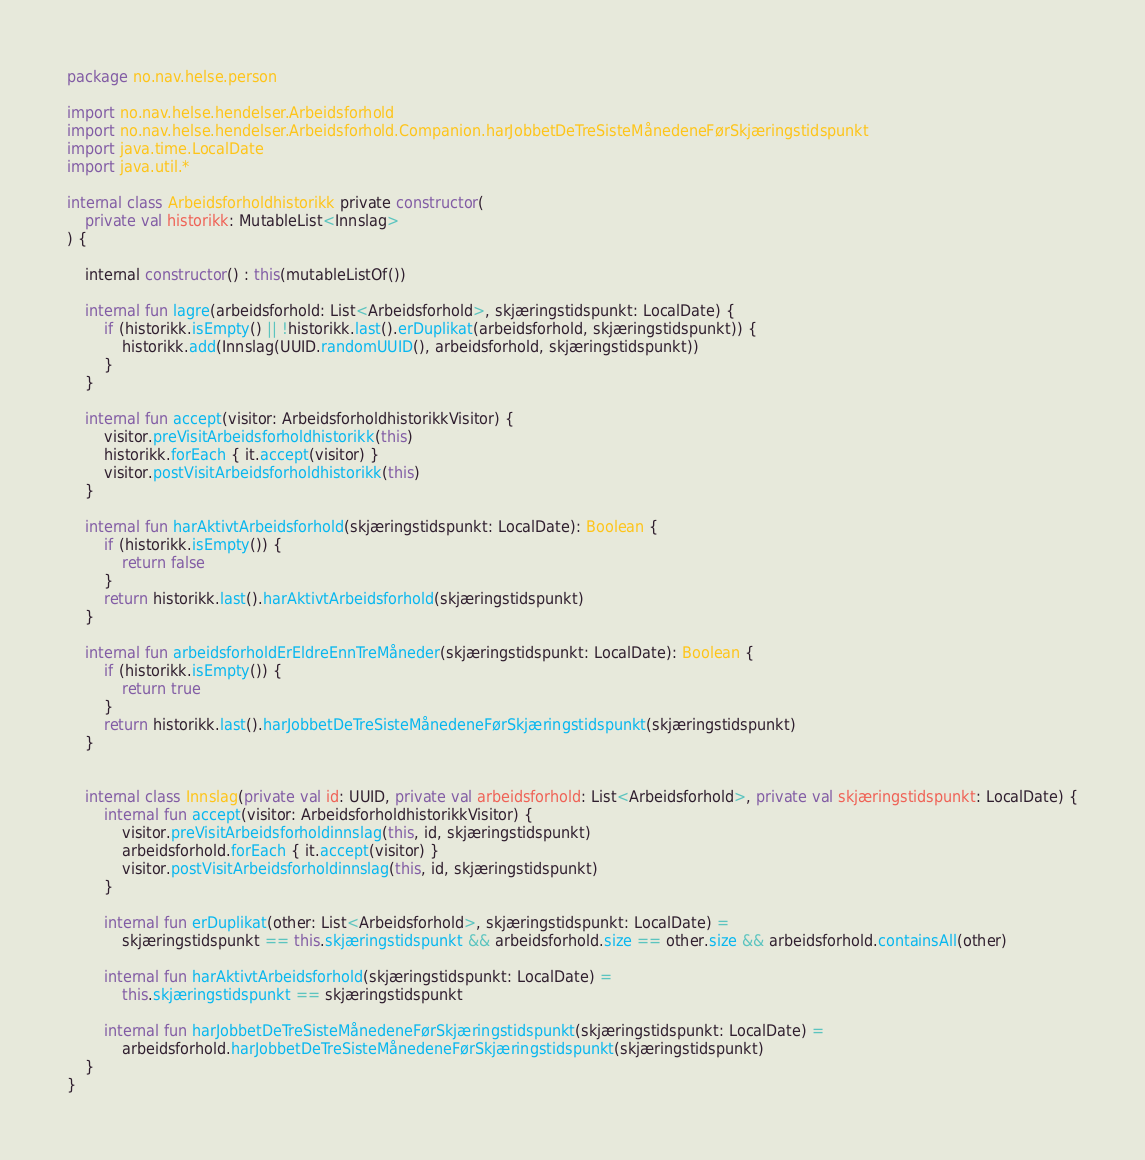Convert code to text. <code><loc_0><loc_0><loc_500><loc_500><_Kotlin_>package no.nav.helse.person

import no.nav.helse.hendelser.Arbeidsforhold
import no.nav.helse.hendelser.Arbeidsforhold.Companion.harJobbetDeTreSisteMånedeneFørSkjæringstidspunkt
import java.time.LocalDate
import java.util.*

internal class Arbeidsforholdhistorikk private constructor(
    private val historikk: MutableList<Innslag>
) {

    internal constructor() : this(mutableListOf())

    internal fun lagre(arbeidsforhold: List<Arbeidsforhold>, skjæringstidspunkt: LocalDate) {
        if (historikk.isEmpty() || !historikk.last().erDuplikat(arbeidsforhold, skjæringstidspunkt)) {
            historikk.add(Innslag(UUID.randomUUID(), arbeidsforhold, skjæringstidspunkt))
        }
    }

    internal fun accept(visitor: ArbeidsforholdhistorikkVisitor) {
        visitor.preVisitArbeidsforholdhistorikk(this)
        historikk.forEach { it.accept(visitor) }
        visitor.postVisitArbeidsforholdhistorikk(this)
    }

    internal fun harAktivtArbeidsforhold(skjæringstidspunkt: LocalDate): Boolean {
        if (historikk.isEmpty()) {
            return false
        }
        return historikk.last().harAktivtArbeidsforhold(skjæringstidspunkt)
    }

    internal fun arbeidsforholdErEldreEnnTreMåneder(skjæringstidspunkt: LocalDate): Boolean {
        if (historikk.isEmpty()) {
            return true
        }
        return historikk.last().harJobbetDeTreSisteMånedeneFørSkjæringstidspunkt(skjæringstidspunkt)
    }


    internal class Innslag(private val id: UUID, private val arbeidsforhold: List<Arbeidsforhold>, private val skjæringstidspunkt: LocalDate) {
        internal fun accept(visitor: ArbeidsforholdhistorikkVisitor) {
            visitor.preVisitArbeidsforholdinnslag(this, id, skjæringstidspunkt)
            arbeidsforhold.forEach { it.accept(visitor) }
            visitor.postVisitArbeidsforholdinnslag(this, id, skjæringstidspunkt)
        }

        internal fun erDuplikat(other: List<Arbeidsforhold>, skjæringstidspunkt: LocalDate) =
            skjæringstidspunkt == this.skjæringstidspunkt && arbeidsforhold.size == other.size && arbeidsforhold.containsAll(other)

        internal fun harAktivtArbeidsforhold(skjæringstidspunkt: LocalDate) =
            this.skjæringstidspunkt == skjæringstidspunkt

        internal fun harJobbetDeTreSisteMånedeneFørSkjæringstidspunkt(skjæringstidspunkt: LocalDate) =
            arbeidsforhold.harJobbetDeTreSisteMånedeneFørSkjæringstidspunkt(skjæringstidspunkt)
    }
}
</code> 